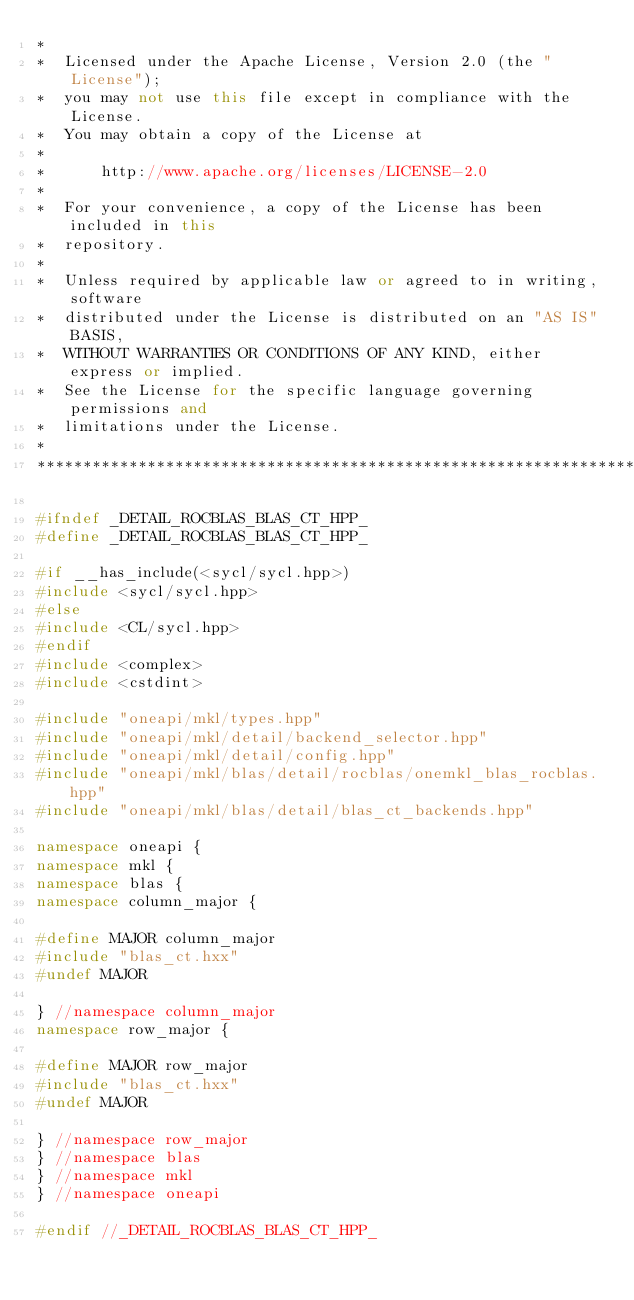Convert code to text. <code><loc_0><loc_0><loc_500><loc_500><_C++_>*
*  Licensed under the Apache License, Version 2.0 (the "License");
*  you may not use this file except in compliance with the License.
*  You may obtain a copy of the License at
*
*      http://www.apache.org/licenses/LICENSE-2.0
*
*  For your convenience, a copy of the License has been included in this
*  repository.
*
*  Unless required by applicable law or agreed to in writing, software
*  distributed under the License is distributed on an "AS IS" BASIS,
*  WITHOUT WARRANTIES OR CONDITIONS OF ANY KIND, either express or implied.
*  See the License for the specific language governing permissions and
*  limitations under the License.
*
**************************************************************************/

#ifndef _DETAIL_ROCBLAS_BLAS_CT_HPP_
#define _DETAIL_ROCBLAS_BLAS_CT_HPP_

#if __has_include(<sycl/sycl.hpp>)
#include <sycl/sycl.hpp>
#else
#include <CL/sycl.hpp>
#endif
#include <complex>
#include <cstdint>

#include "oneapi/mkl/types.hpp"
#include "oneapi/mkl/detail/backend_selector.hpp"
#include "oneapi/mkl/detail/config.hpp"
#include "oneapi/mkl/blas/detail/rocblas/onemkl_blas_rocblas.hpp"
#include "oneapi/mkl/blas/detail/blas_ct_backends.hpp"

namespace oneapi {
namespace mkl {
namespace blas {
namespace column_major {

#define MAJOR column_major
#include "blas_ct.hxx"
#undef MAJOR

} //namespace column_major
namespace row_major {

#define MAJOR row_major
#include "blas_ct.hxx"
#undef MAJOR

} //namespace row_major
} //namespace blas
} //namespace mkl
} //namespace oneapi

#endif //_DETAIL_ROCBLAS_BLAS_CT_HPP_
</code> 